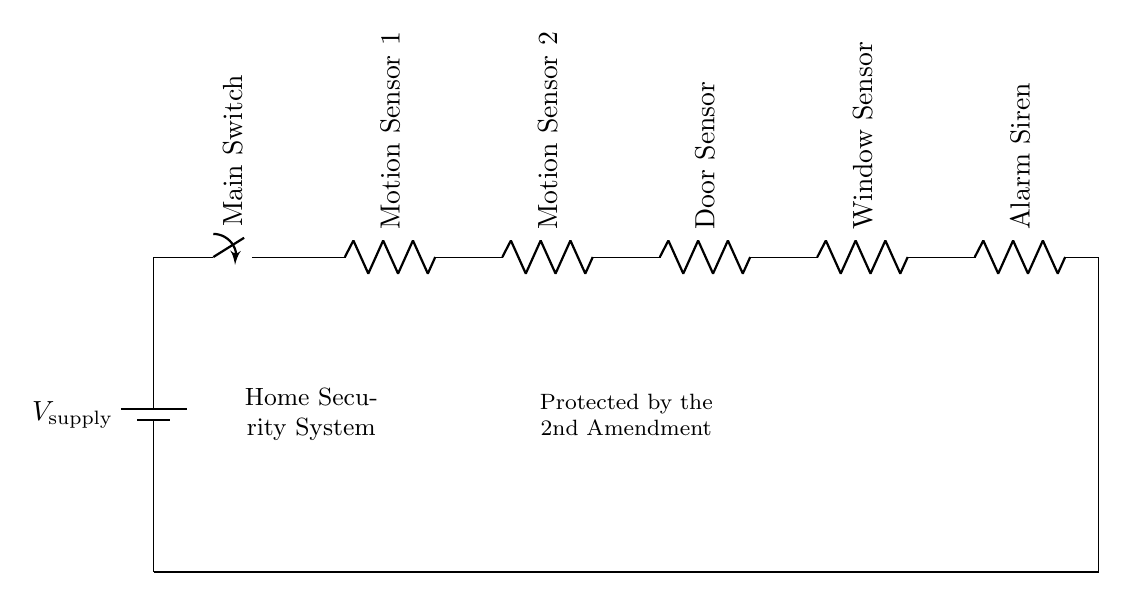What is the supply voltage? The circuit does not specifically indicate a numerical value for the supply voltage, but we can deduce that it's a common voltage used for such circuits, typically 5V or 12V in security systems.
Answer: Not specified How many motion sensors are in the circuit? By counting the components labeled as motion sensors in the circuit diagram, we can see that there are two separate devices indicated as "Motion Sensor 1" and "Motion Sensor 2."
Answer: Two What is the function of the main switch? The main switch in this series circuit controls the flow of electricity. When closed, it allows current to flow through the entire system, while when open, it interrupts the current flow for all devices connected in series.
Answer: Control current flow How many sensors are connected in series before the alarm? By examining the diagram, we can see that there are four sensors (two motion sensors, one door sensor, and one window sensor) connected in series before reaching the alarm component.
Answer: Four What happens if one sensor fails? Since this is a series circuit, the failure of one sensor (such as a break in the circuit) will interrupt the entire current flow, causing all devices downstream, including the alarm, to fail to operate.
Answer: Alarm won't work What does the label "Protected by the 2nd Amendment" suggest? This label indicates a philosophical or legal perspective regarding personal rights to protect one's property, suggesting that the system is intended for personal security in line with constitutional rights.
Answer: Personal security 